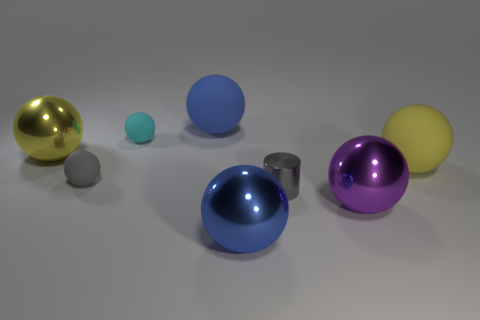There is a yellow ball that is the same material as the cyan object; what is its size?
Offer a terse response. Large. What color is the tiny rubber object behind the yellow object that is on the right side of the gray shiny thing?
Make the answer very short. Cyan. Do the big purple shiny object and the gray object that is in front of the gray sphere have the same shape?
Your answer should be very brief. No. What number of things are the same size as the cyan ball?
Your answer should be compact. 2. There is a tiny cyan thing that is the same shape as the large yellow matte object; what is its material?
Your answer should be compact. Rubber. Do the shiny thing that is right of the tiny cylinder and the big metal thing behind the tiny metal cylinder have the same color?
Keep it short and to the point. No. What shape is the thing that is right of the big purple metal object?
Make the answer very short. Sphere. What color is the metallic cylinder?
Your answer should be very brief. Gray. What is the shape of the purple thing that is the same material as the gray cylinder?
Your response must be concise. Sphere. Does the metallic thing on the left side of the blue rubber thing have the same size as the large purple shiny ball?
Provide a succinct answer. Yes. 